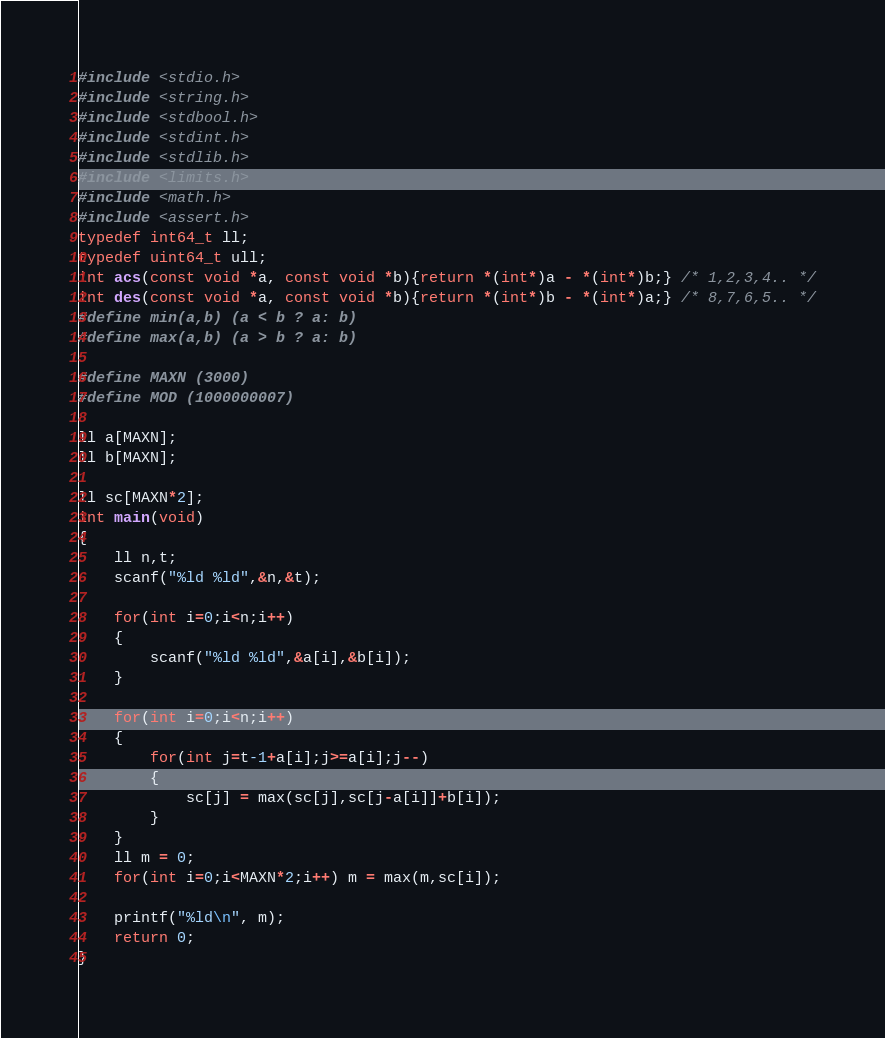Convert code to text. <code><loc_0><loc_0><loc_500><loc_500><_C_>#include <stdio.h>
#include <string.h>
#include <stdbool.h>
#include <stdint.h>
#include <stdlib.h>
#include <limits.h>
#include <math.h>
#include <assert.h>
typedef int64_t ll;
typedef uint64_t ull;
int acs(const void *a, const void *b){return *(int*)a - *(int*)b;} /* 1,2,3,4.. */
int des(const void *a, const void *b){return *(int*)b - *(int*)a;} /* 8,7,6,5.. */
#define min(a,b) (a < b ? a: b)
#define max(a,b) (a > b ? a: b)

#define MAXN (3000)
#define MOD (1000000007)

ll a[MAXN];
ll b[MAXN];

ll sc[MAXN*2];
int main(void)
{
    ll n,t;
    scanf("%ld %ld",&n,&t);

    for(int i=0;i<n;i++)
    {
        scanf("%ld %ld",&a[i],&b[i]);
    }

    for(int i=0;i<n;i++)
    {
        for(int j=t-1+a[i];j>=a[i];j--) 
        {   
            sc[j] = max(sc[j],sc[j-a[i]]+b[i]);
        }
    }
    ll m = 0;
    for(int i=0;i<MAXN*2;i++) m = max(m,sc[i]);
    
    printf("%ld\n", m);
    return 0;
}
</code> 